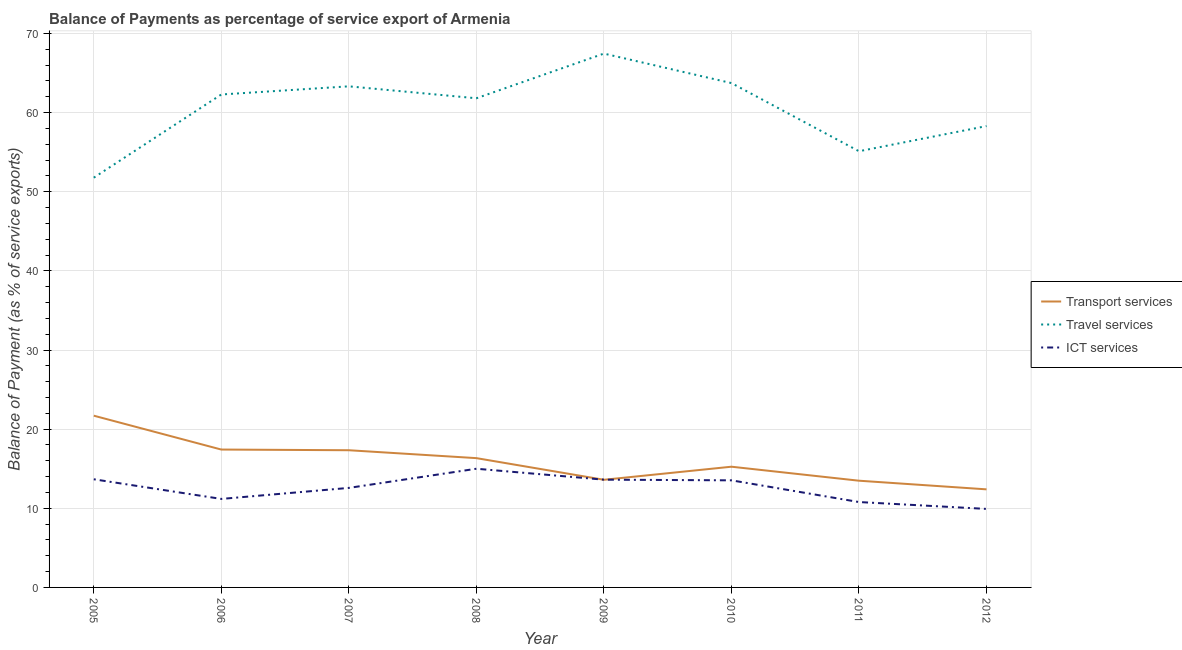Does the line corresponding to balance of payment of ict services intersect with the line corresponding to balance of payment of travel services?
Your answer should be very brief. No. What is the balance of payment of travel services in 2007?
Your answer should be compact. 63.32. Across all years, what is the maximum balance of payment of transport services?
Ensure brevity in your answer.  21.7. Across all years, what is the minimum balance of payment of transport services?
Offer a terse response. 12.39. In which year was the balance of payment of ict services minimum?
Provide a succinct answer. 2012. What is the total balance of payment of ict services in the graph?
Make the answer very short. 100.28. What is the difference between the balance of payment of ict services in 2005 and that in 2006?
Your answer should be compact. 2.48. What is the difference between the balance of payment of transport services in 2008 and the balance of payment of travel services in 2010?
Ensure brevity in your answer.  -47.39. What is the average balance of payment of ict services per year?
Give a very brief answer. 12.54. In the year 2007, what is the difference between the balance of payment of ict services and balance of payment of travel services?
Your response must be concise. -50.74. What is the ratio of the balance of payment of travel services in 2006 to that in 2009?
Offer a very short reply. 0.92. Is the balance of payment of travel services in 2006 less than that in 2008?
Give a very brief answer. No. What is the difference between the highest and the second highest balance of payment of travel services?
Provide a short and direct response. 3.73. What is the difference between the highest and the lowest balance of payment of transport services?
Your answer should be compact. 9.31. Is it the case that in every year, the sum of the balance of payment of transport services and balance of payment of travel services is greater than the balance of payment of ict services?
Provide a short and direct response. Yes. Is the balance of payment of ict services strictly less than the balance of payment of transport services over the years?
Offer a very short reply. No. How many lines are there?
Your answer should be very brief. 3. What is the difference between two consecutive major ticks on the Y-axis?
Ensure brevity in your answer.  10. Are the values on the major ticks of Y-axis written in scientific E-notation?
Provide a short and direct response. No. Where does the legend appear in the graph?
Offer a very short reply. Center right. How many legend labels are there?
Keep it short and to the point. 3. What is the title of the graph?
Ensure brevity in your answer.  Balance of Payments as percentage of service export of Armenia. What is the label or title of the X-axis?
Provide a succinct answer. Year. What is the label or title of the Y-axis?
Your answer should be very brief. Balance of Payment (as % of service exports). What is the Balance of Payment (as % of service exports) in Transport services in 2005?
Your answer should be very brief. 21.7. What is the Balance of Payment (as % of service exports) in Travel services in 2005?
Ensure brevity in your answer.  51.78. What is the Balance of Payment (as % of service exports) in ICT services in 2005?
Provide a succinct answer. 13.67. What is the Balance of Payment (as % of service exports) in Transport services in 2006?
Your answer should be very brief. 17.42. What is the Balance of Payment (as % of service exports) in Travel services in 2006?
Make the answer very short. 62.29. What is the Balance of Payment (as % of service exports) in ICT services in 2006?
Your response must be concise. 11.18. What is the Balance of Payment (as % of service exports) of Transport services in 2007?
Your answer should be very brief. 17.34. What is the Balance of Payment (as % of service exports) in Travel services in 2007?
Give a very brief answer. 63.32. What is the Balance of Payment (as % of service exports) in ICT services in 2007?
Offer a very short reply. 12.58. What is the Balance of Payment (as % of service exports) of Transport services in 2008?
Offer a very short reply. 16.34. What is the Balance of Payment (as % of service exports) in Travel services in 2008?
Your answer should be compact. 61.81. What is the Balance of Payment (as % of service exports) in ICT services in 2008?
Provide a short and direct response. 15. What is the Balance of Payment (as % of service exports) of Transport services in 2009?
Your answer should be compact. 13.6. What is the Balance of Payment (as % of service exports) in Travel services in 2009?
Offer a terse response. 67.46. What is the Balance of Payment (as % of service exports) of ICT services in 2009?
Your response must be concise. 13.62. What is the Balance of Payment (as % of service exports) in Transport services in 2010?
Provide a short and direct response. 15.25. What is the Balance of Payment (as % of service exports) of Travel services in 2010?
Your response must be concise. 63.73. What is the Balance of Payment (as % of service exports) in ICT services in 2010?
Keep it short and to the point. 13.53. What is the Balance of Payment (as % of service exports) of Transport services in 2011?
Your answer should be compact. 13.49. What is the Balance of Payment (as % of service exports) in Travel services in 2011?
Offer a terse response. 55.12. What is the Balance of Payment (as % of service exports) of ICT services in 2011?
Provide a short and direct response. 10.79. What is the Balance of Payment (as % of service exports) of Transport services in 2012?
Provide a succinct answer. 12.39. What is the Balance of Payment (as % of service exports) in Travel services in 2012?
Ensure brevity in your answer.  58.3. What is the Balance of Payment (as % of service exports) of ICT services in 2012?
Keep it short and to the point. 9.92. Across all years, what is the maximum Balance of Payment (as % of service exports) in Transport services?
Offer a very short reply. 21.7. Across all years, what is the maximum Balance of Payment (as % of service exports) of Travel services?
Ensure brevity in your answer.  67.46. Across all years, what is the maximum Balance of Payment (as % of service exports) of ICT services?
Your response must be concise. 15. Across all years, what is the minimum Balance of Payment (as % of service exports) of Transport services?
Offer a terse response. 12.39. Across all years, what is the minimum Balance of Payment (as % of service exports) in Travel services?
Your answer should be compact. 51.78. Across all years, what is the minimum Balance of Payment (as % of service exports) in ICT services?
Your answer should be compact. 9.92. What is the total Balance of Payment (as % of service exports) in Transport services in the graph?
Make the answer very short. 127.53. What is the total Balance of Payment (as % of service exports) in Travel services in the graph?
Your answer should be very brief. 483.8. What is the total Balance of Payment (as % of service exports) in ICT services in the graph?
Give a very brief answer. 100.28. What is the difference between the Balance of Payment (as % of service exports) in Transport services in 2005 and that in 2006?
Ensure brevity in your answer.  4.28. What is the difference between the Balance of Payment (as % of service exports) of Travel services in 2005 and that in 2006?
Offer a very short reply. -10.51. What is the difference between the Balance of Payment (as % of service exports) of ICT services in 2005 and that in 2006?
Offer a very short reply. 2.48. What is the difference between the Balance of Payment (as % of service exports) in Transport services in 2005 and that in 2007?
Make the answer very short. 4.37. What is the difference between the Balance of Payment (as % of service exports) in Travel services in 2005 and that in 2007?
Your answer should be compact. -11.54. What is the difference between the Balance of Payment (as % of service exports) of ICT services in 2005 and that in 2007?
Provide a succinct answer. 1.09. What is the difference between the Balance of Payment (as % of service exports) of Transport services in 2005 and that in 2008?
Offer a terse response. 5.36. What is the difference between the Balance of Payment (as % of service exports) in Travel services in 2005 and that in 2008?
Offer a terse response. -10.03. What is the difference between the Balance of Payment (as % of service exports) of ICT services in 2005 and that in 2008?
Make the answer very short. -1.33. What is the difference between the Balance of Payment (as % of service exports) in Transport services in 2005 and that in 2009?
Ensure brevity in your answer.  8.1. What is the difference between the Balance of Payment (as % of service exports) of Travel services in 2005 and that in 2009?
Your answer should be very brief. -15.68. What is the difference between the Balance of Payment (as % of service exports) of ICT services in 2005 and that in 2009?
Provide a short and direct response. 0.05. What is the difference between the Balance of Payment (as % of service exports) of Transport services in 2005 and that in 2010?
Ensure brevity in your answer.  6.45. What is the difference between the Balance of Payment (as % of service exports) of Travel services in 2005 and that in 2010?
Offer a very short reply. -11.95. What is the difference between the Balance of Payment (as % of service exports) of ICT services in 2005 and that in 2010?
Your response must be concise. 0.13. What is the difference between the Balance of Payment (as % of service exports) of Transport services in 2005 and that in 2011?
Offer a terse response. 8.22. What is the difference between the Balance of Payment (as % of service exports) in Travel services in 2005 and that in 2011?
Keep it short and to the point. -3.34. What is the difference between the Balance of Payment (as % of service exports) of ICT services in 2005 and that in 2011?
Your response must be concise. 2.88. What is the difference between the Balance of Payment (as % of service exports) in Transport services in 2005 and that in 2012?
Provide a short and direct response. 9.31. What is the difference between the Balance of Payment (as % of service exports) in Travel services in 2005 and that in 2012?
Keep it short and to the point. -6.52. What is the difference between the Balance of Payment (as % of service exports) of ICT services in 2005 and that in 2012?
Keep it short and to the point. 3.75. What is the difference between the Balance of Payment (as % of service exports) of Transport services in 2006 and that in 2007?
Offer a terse response. 0.09. What is the difference between the Balance of Payment (as % of service exports) in Travel services in 2006 and that in 2007?
Your answer should be very brief. -1.03. What is the difference between the Balance of Payment (as % of service exports) in ICT services in 2006 and that in 2007?
Your answer should be compact. -1.39. What is the difference between the Balance of Payment (as % of service exports) in Transport services in 2006 and that in 2008?
Your answer should be very brief. 1.08. What is the difference between the Balance of Payment (as % of service exports) in Travel services in 2006 and that in 2008?
Make the answer very short. 0.48. What is the difference between the Balance of Payment (as % of service exports) of ICT services in 2006 and that in 2008?
Provide a succinct answer. -3.81. What is the difference between the Balance of Payment (as % of service exports) of Transport services in 2006 and that in 2009?
Give a very brief answer. 3.82. What is the difference between the Balance of Payment (as % of service exports) of Travel services in 2006 and that in 2009?
Provide a short and direct response. -5.17. What is the difference between the Balance of Payment (as % of service exports) of ICT services in 2006 and that in 2009?
Make the answer very short. -2.43. What is the difference between the Balance of Payment (as % of service exports) of Transport services in 2006 and that in 2010?
Make the answer very short. 2.17. What is the difference between the Balance of Payment (as % of service exports) of Travel services in 2006 and that in 2010?
Ensure brevity in your answer.  -1.44. What is the difference between the Balance of Payment (as % of service exports) in ICT services in 2006 and that in 2010?
Offer a terse response. -2.35. What is the difference between the Balance of Payment (as % of service exports) in Transport services in 2006 and that in 2011?
Provide a succinct answer. 3.94. What is the difference between the Balance of Payment (as % of service exports) in Travel services in 2006 and that in 2011?
Your answer should be very brief. 7.17. What is the difference between the Balance of Payment (as % of service exports) of ICT services in 2006 and that in 2011?
Give a very brief answer. 0.4. What is the difference between the Balance of Payment (as % of service exports) in Transport services in 2006 and that in 2012?
Your response must be concise. 5.03. What is the difference between the Balance of Payment (as % of service exports) in Travel services in 2006 and that in 2012?
Keep it short and to the point. 3.99. What is the difference between the Balance of Payment (as % of service exports) in ICT services in 2006 and that in 2012?
Provide a succinct answer. 1.26. What is the difference between the Balance of Payment (as % of service exports) in Travel services in 2007 and that in 2008?
Your answer should be compact. 1.51. What is the difference between the Balance of Payment (as % of service exports) of ICT services in 2007 and that in 2008?
Provide a short and direct response. -2.42. What is the difference between the Balance of Payment (as % of service exports) of Transport services in 2007 and that in 2009?
Your answer should be compact. 3.73. What is the difference between the Balance of Payment (as % of service exports) in Travel services in 2007 and that in 2009?
Your answer should be compact. -4.14. What is the difference between the Balance of Payment (as % of service exports) in ICT services in 2007 and that in 2009?
Your response must be concise. -1.04. What is the difference between the Balance of Payment (as % of service exports) of Transport services in 2007 and that in 2010?
Provide a short and direct response. 2.08. What is the difference between the Balance of Payment (as % of service exports) in Travel services in 2007 and that in 2010?
Provide a succinct answer. -0.41. What is the difference between the Balance of Payment (as % of service exports) of ICT services in 2007 and that in 2010?
Your answer should be compact. -0.96. What is the difference between the Balance of Payment (as % of service exports) in Transport services in 2007 and that in 2011?
Keep it short and to the point. 3.85. What is the difference between the Balance of Payment (as % of service exports) of Travel services in 2007 and that in 2011?
Keep it short and to the point. 8.2. What is the difference between the Balance of Payment (as % of service exports) in ICT services in 2007 and that in 2011?
Offer a very short reply. 1.79. What is the difference between the Balance of Payment (as % of service exports) in Transport services in 2007 and that in 2012?
Offer a very short reply. 4.94. What is the difference between the Balance of Payment (as % of service exports) in Travel services in 2007 and that in 2012?
Give a very brief answer. 5.02. What is the difference between the Balance of Payment (as % of service exports) in ICT services in 2007 and that in 2012?
Your answer should be very brief. 2.66. What is the difference between the Balance of Payment (as % of service exports) in Transport services in 2008 and that in 2009?
Your answer should be very brief. 2.73. What is the difference between the Balance of Payment (as % of service exports) in Travel services in 2008 and that in 2009?
Your answer should be very brief. -5.65. What is the difference between the Balance of Payment (as % of service exports) of ICT services in 2008 and that in 2009?
Make the answer very short. 1.38. What is the difference between the Balance of Payment (as % of service exports) in Transport services in 2008 and that in 2010?
Provide a succinct answer. 1.08. What is the difference between the Balance of Payment (as % of service exports) of Travel services in 2008 and that in 2010?
Give a very brief answer. -1.92. What is the difference between the Balance of Payment (as % of service exports) of ICT services in 2008 and that in 2010?
Your response must be concise. 1.47. What is the difference between the Balance of Payment (as % of service exports) of Transport services in 2008 and that in 2011?
Your answer should be compact. 2.85. What is the difference between the Balance of Payment (as % of service exports) in Travel services in 2008 and that in 2011?
Ensure brevity in your answer.  6.69. What is the difference between the Balance of Payment (as % of service exports) in ICT services in 2008 and that in 2011?
Make the answer very short. 4.21. What is the difference between the Balance of Payment (as % of service exports) in Transport services in 2008 and that in 2012?
Make the answer very short. 3.94. What is the difference between the Balance of Payment (as % of service exports) in Travel services in 2008 and that in 2012?
Your answer should be very brief. 3.51. What is the difference between the Balance of Payment (as % of service exports) in ICT services in 2008 and that in 2012?
Make the answer very short. 5.08. What is the difference between the Balance of Payment (as % of service exports) in Transport services in 2009 and that in 2010?
Your answer should be compact. -1.65. What is the difference between the Balance of Payment (as % of service exports) in Travel services in 2009 and that in 2010?
Offer a terse response. 3.73. What is the difference between the Balance of Payment (as % of service exports) of ICT services in 2009 and that in 2010?
Offer a very short reply. 0.08. What is the difference between the Balance of Payment (as % of service exports) in Transport services in 2009 and that in 2011?
Provide a succinct answer. 0.12. What is the difference between the Balance of Payment (as % of service exports) of Travel services in 2009 and that in 2011?
Make the answer very short. 12.34. What is the difference between the Balance of Payment (as % of service exports) in ICT services in 2009 and that in 2011?
Make the answer very short. 2.83. What is the difference between the Balance of Payment (as % of service exports) in Transport services in 2009 and that in 2012?
Ensure brevity in your answer.  1.21. What is the difference between the Balance of Payment (as % of service exports) in Travel services in 2009 and that in 2012?
Your answer should be very brief. 9.16. What is the difference between the Balance of Payment (as % of service exports) of ICT services in 2009 and that in 2012?
Provide a succinct answer. 3.7. What is the difference between the Balance of Payment (as % of service exports) in Transport services in 2010 and that in 2011?
Give a very brief answer. 1.77. What is the difference between the Balance of Payment (as % of service exports) in Travel services in 2010 and that in 2011?
Your answer should be very brief. 8.61. What is the difference between the Balance of Payment (as % of service exports) in ICT services in 2010 and that in 2011?
Keep it short and to the point. 2.74. What is the difference between the Balance of Payment (as % of service exports) in Transport services in 2010 and that in 2012?
Keep it short and to the point. 2.86. What is the difference between the Balance of Payment (as % of service exports) of Travel services in 2010 and that in 2012?
Offer a terse response. 5.43. What is the difference between the Balance of Payment (as % of service exports) in ICT services in 2010 and that in 2012?
Your answer should be very brief. 3.61. What is the difference between the Balance of Payment (as % of service exports) in Transport services in 2011 and that in 2012?
Ensure brevity in your answer.  1.09. What is the difference between the Balance of Payment (as % of service exports) in Travel services in 2011 and that in 2012?
Your response must be concise. -3.18. What is the difference between the Balance of Payment (as % of service exports) of ICT services in 2011 and that in 2012?
Your answer should be very brief. 0.87. What is the difference between the Balance of Payment (as % of service exports) in Transport services in 2005 and the Balance of Payment (as % of service exports) in Travel services in 2006?
Provide a short and direct response. -40.59. What is the difference between the Balance of Payment (as % of service exports) of Transport services in 2005 and the Balance of Payment (as % of service exports) of ICT services in 2006?
Ensure brevity in your answer.  10.52. What is the difference between the Balance of Payment (as % of service exports) in Travel services in 2005 and the Balance of Payment (as % of service exports) in ICT services in 2006?
Offer a very short reply. 40.59. What is the difference between the Balance of Payment (as % of service exports) of Transport services in 2005 and the Balance of Payment (as % of service exports) of Travel services in 2007?
Keep it short and to the point. -41.62. What is the difference between the Balance of Payment (as % of service exports) in Transport services in 2005 and the Balance of Payment (as % of service exports) in ICT services in 2007?
Offer a terse response. 9.13. What is the difference between the Balance of Payment (as % of service exports) of Travel services in 2005 and the Balance of Payment (as % of service exports) of ICT services in 2007?
Provide a short and direct response. 39.2. What is the difference between the Balance of Payment (as % of service exports) in Transport services in 2005 and the Balance of Payment (as % of service exports) in Travel services in 2008?
Your response must be concise. -40.11. What is the difference between the Balance of Payment (as % of service exports) of Transport services in 2005 and the Balance of Payment (as % of service exports) of ICT services in 2008?
Your answer should be compact. 6.7. What is the difference between the Balance of Payment (as % of service exports) in Travel services in 2005 and the Balance of Payment (as % of service exports) in ICT services in 2008?
Offer a very short reply. 36.78. What is the difference between the Balance of Payment (as % of service exports) of Transport services in 2005 and the Balance of Payment (as % of service exports) of Travel services in 2009?
Offer a very short reply. -45.75. What is the difference between the Balance of Payment (as % of service exports) in Transport services in 2005 and the Balance of Payment (as % of service exports) in ICT services in 2009?
Offer a very short reply. 8.09. What is the difference between the Balance of Payment (as % of service exports) of Travel services in 2005 and the Balance of Payment (as % of service exports) of ICT services in 2009?
Make the answer very short. 38.16. What is the difference between the Balance of Payment (as % of service exports) of Transport services in 2005 and the Balance of Payment (as % of service exports) of Travel services in 2010?
Your answer should be compact. -42.03. What is the difference between the Balance of Payment (as % of service exports) of Transport services in 2005 and the Balance of Payment (as % of service exports) of ICT services in 2010?
Ensure brevity in your answer.  8.17. What is the difference between the Balance of Payment (as % of service exports) in Travel services in 2005 and the Balance of Payment (as % of service exports) in ICT services in 2010?
Your answer should be very brief. 38.24. What is the difference between the Balance of Payment (as % of service exports) of Transport services in 2005 and the Balance of Payment (as % of service exports) of Travel services in 2011?
Ensure brevity in your answer.  -33.42. What is the difference between the Balance of Payment (as % of service exports) in Transport services in 2005 and the Balance of Payment (as % of service exports) in ICT services in 2011?
Keep it short and to the point. 10.91. What is the difference between the Balance of Payment (as % of service exports) in Travel services in 2005 and the Balance of Payment (as % of service exports) in ICT services in 2011?
Give a very brief answer. 40.99. What is the difference between the Balance of Payment (as % of service exports) in Transport services in 2005 and the Balance of Payment (as % of service exports) in Travel services in 2012?
Make the answer very short. -36.6. What is the difference between the Balance of Payment (as % of service exports) of Transport services in 2005 and the Balance of Payment (as % of service exports) of ICT services in 2012?
Make the answer very short. 11.78. What is the difference between the Balance of Payment (as % of service exports) in Travel services in 2005 and the Balance of Payment (as % of service exports) in ICT services in 2012?
Your response must be concise. 41.86. What is the difference between the Balance of Payment (as % of service exports) in Transport services in 2006 and the Balance of Payment (as % of service exports) in Travel services in 2007?
Provide a succinct answer. -45.9. What is the difference between the Balance of Payment (as % of service exports) in Transport services in 2006 and the Balance of Payment (as % of service exports) in ICT services in 2007?
Offer a very short reply. 4.85. What is the difference between the Balance of Payment (as % of service exports) of Travel services in 2006 and the Balance of Payment (as % of service exports) of ICT services in 2007?
Your answer should be very brief. 49.71. What is the difference between the Balance of Payment (as % of service exports) of Transport services in 2006 and the Balance of Payment (as % of service exports) of Travel services in 2008?
Give a very brief answer. -44.39. What is the difference between the Balance of Payment (as % of service exports) in Transport services in 2006 and the Balance of Payment (as % of service exports) in ICT services in 2008?
Make the answer very short. 2.42. What is the difference between the Balance of Payment (as % of service exports) of Travel services in 2006 and the Balance of Payment (as % of service exports) of ICT services in 2008?
Keep it short and to the point. 47.29. What is the difference between the Balance of Payment (as % of service exports) of Transport services in 2006 and the Balance of Payment (as % of service exports) of Travel services in 2009?
Give a very brief answer. -50.04. What is the difference between the Balance of Payment (as % of service exports) of Transport services in 2006 and the Balance of Payment (as % of service exports) of ICT services in 2009?
Give a very brief answer. 3.81. What is the difference between the Balance of Payment (as % of service exports) in Travel services in 2006 and the Balance of Payment (as % of service exports) in ICT services in 2009?
Ensure brevity in your answer.  48.67. What is the difference between the Balance of Payment (as % of service exports) of Transport services in 2006 and the Balance of Payment (as % of service exports) of Travel services in 2010?
Offer a very short reply. -46.31. What is the difference between the Balance of Payment (as % of service exports) of Transport services in 2006 and the Balance of Payment (as % of service exports) of ICT services in 2010?
Keep it short and to the point. 3.89. What is the difference between the Balance of Payment (as % of service exports) of Travel services in 2006 and the Balance of Payment (as % of service exports) of ICT services in 2010?
Ensure brevity in your answer.  48.76. What is the difference between the Balance of Payment (as % of service exports) of Transport services in 2006 and the Balance of Payment (as % of service exports) of Travel services in 2011?
Give a very brief answer. -37.7. What is the difference between the Balance of Payment (as % of service exports) in Transport services in 2006 and the Balance of Payment (as % of service exports) in ICT services in 2011?
Make the answer very short. 6.63. What is the difference between the Balance of Payment (as % of service exports) of Travel services in 2006 and the Balance of Payment (as % of service exports) of ICT services in 2011?
Your answer should be very brief. 51.5. What is the difference between the Balance of Payment (as % of service exports) in Transport services in 2006 and the Balance of Payment (as % of service exports) in Travel services in 2012?
Your answer should be compact. -40.88. What is the difference between the Balance of Payment (as % of service exports) in Transport services in 2006 and the Balance of Payment (as % of service exports) in ICT services in 2012?
Provide a short and direct response. 7.5. What is the difference between the Balance of Payment (as % of service exports) of Travel services in 2006 and the Balance of Payment (as % of service exports) of ICT services in 2012?
Your answer should be compact. 52.37. What is the difference between the Balance of Payment (as % of service exports) of Transport services in 2007 and the Balance of Payment (as % of service exports) of Travel services in 2008?
Your answer should be very brief. -44.48. What is the difference between the Balance of Payment (as % of service exports) of Transport services in 2007 and the Balance of Payment (as % of service exports) of ICT services in 2008?
Provide a succinct answer. 2.34. What is the difference between the Balance of Payment (as % of service exports) of Travel services in 2007 and the Balance of Payment (as % of service exports) of ICT services in 2008?
Offer a very short reply. 48.32. What is the difference between the Balance of Payment (as % of service exports) in Transport services in 2007 and the Balance of Payment (as % of service exports) in Travel services in 2009?
Provide a succinct answer. -50.12. What is the difference between the Balance of Payment (as % of service exports) in Transport services in 2007 and the Balance of Payment (as % of service exports) in ICT services in 2009?
Ensure brevity in your answer.  3.72. What is the difference between the Balance of Payment (as % of service exports) in Travel services in 2007 and the Balance of Payment (as % of service exports) in ICT services in 2009?
Offer a terse response. 49.7. What is the difference between the Balance of Payment (as % of service exports) in Transport services in 2007 and the Balance of Payment (as % of service exports) in Travel services in 2010?
Offer a terse response. -46.4. What is the difference between the Balance of Payment (as % of service exports) in Transport services in 2007 and the Balance of Payment (as % of service exports) in ICT services in 2010?
Provide a succinct answer. 3.8. What is the difference between the Balance of Payment (as % of service exports) of Travel services in 2007 and the Balance of Payment (as % of service exports) of ICT services in 2010?
Offer a very short reply. 49.79. What is the difference between the Balance of Payment (as % of service exports) in Transport services in 2007 and the Balance of Payment (as % of service exports) in Travel services in 2011?
Keep it short and to the point. -37.78. What is the difference between the Balance of Payment (as % of service exports) of Transport services in 2007 and the Balance of Payment (as % of service exports) of ICT services in 2011?
Keep it short and to the point. 6.55. What is the difference between the Balance of Payment (as % of service exports) in Travel services in 2007 and the Balance of Payment (as % of service exports) in ICT services in 2011?
Offer a very short reply. 52.53. What is the difference between the Balance of Payment (as % of service exports) of Transport services in 2007 and the Balance of Payment (as % of service exports) of Travel services in 2012?
Give a very brief answer. -40.96. What is the difference between the Balance of Payment (as % of service exports) of Transport services in 2007 and the Balance of Payment (as % of service exports) of ICT services in 2012?
Ensure brevity in your answer.  7.41. What is the difference between the Balance of Payment (as % of service exports) of Travel services in 2007 and the Balance of Payment (as % of service exports) of ICT services in 2012?
Your answer should be very brief. 53.4. What is the difference between the Balance of Payment (as % of service exports) of Transport services in 2008 and the Balance of Payment (as % of service exports) of Travel services in 2009?
Keep it short and to the point. -51.12. What is the difference between the Balance of Payment (as % of service exports) in Transport services in 2008 and the Balance of Payment (as % of service exports) in ICT services in 2009?
Your answer should be compact. 2.72. What is the difference between the Balance of Payment (as % of service exports) in Travel services in 2008 and the Balance of Payment (as % of service exports) in ICT services in 2009?
Offer a terse response. 48.19. What is the difference between the Balance of Payment (as % of service exports) in Transport services in 2008 and the Balance of Payment (as % of service exports) in Travel services in 2010?
Your answer should be very brief. -47.39. What is the difference between the Balance of Payment (as % of service exports) in Transport services in 2008 and the Balance of Payment (as % of service exports) in ICT services in 2010?
Offer a very short reply. 2.81. What is the difference between the Balance of Payment (as % of service exports) of Travel services in 2008 and the Balance of Payment (as % of service exports) of ICT services in 2010?
Provide a short and direct response. 48.28. What is the difference between the Balance of Payment (as % of service exports) in Transport services in 2008 and the Balance of Payment (as % of service exports) in Travel services in 2011?
Keep it short and to the point. -38.78. What is the difference between the Balance of Payment (as % of service exports) in Transport services in 2008 and the Balance of Payment (as % of service exports) in ICT services in 2011?
Give a very brief answer. 5.55. What is the difference between the Balance of Payment (as % of service exports) of Travel services in 2008 and the Balance of Payment (as % of service exports) of ICT services in 2011?
Give a very brief answer. 51.02. What is the difference between the Balance of Payment (as % of service exports) in Transport services in 2008 and the Balance of Payment (as % of service exports) in Travel services in 2012?
Give a very brief answer. -41.96. What is the difference between the Balance of Payment (as % of service exports) in Transport services in 2008 and the Balance of Payment (as % of service exports) in ICT services in 2012?
Ensure brevity in your answer.  6.42. What is the difference between the Balance of Payment (as % of service exports) of Travel services in 2008 and the Balance of Payment (as % of service exports) of ICT services in 2012?
Offer a very short reply. 51.89. What is the difference between the Balance of Payment (as % of service exports) of Transport services in 2009 and the Balance of Payment (as % of service exports) of Travel services in 2010?
Ensure brevity in your answer.  -50.13. What is the difference between the Balance of Payment (as % of service exports) of Transport services in 2009 and the Balance of Payment (as % of service exports) of ICT services in 2010?
Your answer should be compact. 0.07. What is the difference between the Balance of Payment (as % of service exports) in Travel services in 2009 and the Balance of Payment (as % of service exports) in ICT services in 2010?
Make the answer very short. 53.92. What is the difference between the Balance of Payment (as % of service exports) in Transport services in 2009 and the Balance of Payment (as % of service exports) in Travel services in 2011?
Offer a very short reply. -41.51. What is the difference between the Balance of Payment (as % of service exports) in Transport services in 2009 and the Balance of Payment (as % of service exports) in ICT services in 2011?
Offer a very short reply. 2.81. What is the difference between the Balance of Payment (as % of service exports) in Travel services in 2009 and the Balance of Payment (as % of service exports) in ICT services in 2011?
Provide a short and direct response. 56.67. What is the difference between the Balance of Payment (as % of service exports) in Transport services in 2009 and the Balance of Payment (as % of service exports) in Travel services in 2012?
Your answer should be very brief. -44.69. What is the difference between the Balance of Payment (as % of service exports) in Transport services in 2009 and the Balance of Payment (as % of service exports) in ICT services in 2012?
Give a very brief answer. 3.68. What is the difference between the Balance of Payment (as % of service exports) in Travel services in 2009 and the Balance of Payment (as % of service exports) in ICT services in 2012?
Your answer should be compact. 57.54. What is the difference between the Balance of Payment (as % of service exports) of Transport services in 2010 and the Balance of Payment (as % of service exports) of Travel services in 2011?
Your response must be concise. -39.86. What is the difference between the Balance of Payment (as % of service exports) in Transport services in 2010 and the Balance of Payment (as % of service exports) in ICT services in 2011?
Your answer should be compact. 4.47. What is the difference between the Balance of Payment (as % of service exports) in Travel services in 2010 and the Balance of Payment (as % of service exports) in ICT services in 2011?
Give a very brief answer. 52.94. What is the difference between the Balance of Payment (as % of service exports) in Transport services in 2010 and the Balance of Payment (as % of service exports) in Travel services in 2012?
Provide a short and direct response. -43.04. What is the difference between the Balance of Payment (as % of service exports) of Transport services in 2010 and the Balance of Payment (as % of service exports) of ICT services in 2012?
Your response must be concise. 5.33. What is the difference between the Balance of Payment (as % of service exports) in Travel services in 2010 and the Balance of Payment (as % of service exports) in ICT services in 2012?
Keep it short and to the point. 53.81. What is the difference between the Balance of Payment (as % of service exports) of Transport services in 2011 and the Balance of Payment (as % of service exports) of Travel services in 2012?
Provide a short and direct response. -44.81. What is the difference between the Balance of Payment (as % of service exports) in Transport services in 2011 and the Balance of Payment (as % of service exports) in ICT services in 2012?
Keep it short and to the point. 3.56. What is the difference between the Balance of Payment (as % of service exports) of Travel services in 2011 and the Balance of Payment (as % of service exports) of ICT services in 2012?
Give a very brief answer. 45.2. What is the average Balance of Payment (as % of service exports) of Transport services per year?
Offer a very short reply. 15.94. What is the average Balance of Payment (as % of service exports) in Travel services per year?
Your answer should be very brief. 60.48. What is the average Balance of Payment (as % of service exports) of ICT services per year?
Provide a succinct answer. 12.54. In the year 2005, what is the difference between the Balance of Payment (as % of service exports) of Transport services and Balance of Payment (as % of service exports) of Travel services?
Provide a short and direct response. -30.07. In the year 2005, what is the difference between the Balance of Payment (as % of service exports) of Transport services and Balance of Payment (as % of service exports) of ICT services?
Offer a very short reply. 8.04. In the year 2005, what is the difference between the Balance of Payment (as % of service exports) in Travel services and Balance of Payment (as % of service exports) in ICT services?
Your answer should be very brief. 38.11. In the year 2006, what is the difference between the Balance of Payment (as % of service exports) in Transport services and Balance of Payment (as % of service exports) in Travel services?
Ensure brevity in your answer.  -44.87. In the year 2006, what is the difference between the Balance of Payment (as % of service exports) of Transport services and Balance of Payment (as % of service exports) of ICT services?
Make the answer very short. 6.24. In the year 2006, what is the difference between the Balance of Payment (as % of service exports) of Travel services and Balance of Payment (as % of service exports) of ICT services?
Keep it short and to the point. 51.11. In the year 2007, what is the difference between the Balance of Payment (as % of service exports) in Transport services and Balance of Payment (as % of service exports) in Travel services?
Your answer should be very brief. -45.98. In the year 2007, what is the difference between the Balance of Payment (as % of service exports) in Transport services and Balance of Payment (as % of service exports) in ICT services?
Your answer should be compact. 4.76. In the year 2007, what is the difference between the Balance of Payment (as % of service exports) in Travel services and Balance of Payment (as % of service exports) in ICT services?
Offer a very short reply. 50.74. In the year 2008, what is the difference between the Balance of Payment (as % of service exports) of Transport services and Balance of Payment (as % of service exports) of Travel services?
Your answer should be compact. -45.47. In the year 2008, what is the difference between the Balance of Payment (as % of service exports) of Transport services and Balance of Payment (as % of service exports) of ICT services?
Make the answer very short. 1.34. In the year 2008, what is the difference between the Balance of Payment (as % of service exports) in Travel services and Balance of Payment (as % of service exports) in ICT services?
Your response must be concise. 46.81. In the year 2009, what is the difference between the Balance of Payment (as % of service exports) in Transport services and Balance of Payment (as % of service exports) in Travel services?
Your answer should be very brief. -53.85. In the year 2009, what is the difference between the Balance of Payment (as % of service exports) in Transport services and Balance of Payment (as % of service exports) in ICT services?
Provide a succinct answer. -0.01. In the year 2009, what is the difference between the Balance of Payment (as % of service exports) in Travel services and Balance of Payment (as % of service exports) in ICT services?
Offer a terse response. 53.84. In the year 2010, what is the difference between the Balance of Payment (as % of service exports) of Transport services and Balance of Payment (as % of service exports) of Travel services?
Provide a short and direct response. -48.48. In the year 2010, what is the difference between the Balance of Payment (as % of service exports) in Transport services and Balance of Payment (as % of service exports) in ICT services?
Your response must be concise. 1.72. In the year 2010, what is the difference between the Balance of Payment (as % of service exports) of Travel services and Balance of Payment (as % of service exports) of ICT services?
Ensure brevity in your answer.  50.2. In the year 2011, what is the difference between the Balance of Payment (as % of service exports) in Transport services and Balance of Payment (as % of service exports) in Travel services?
Give a very brief answer. -41.63. In the year 2011, what is the difference between the Balance of Payment (as % of service exports) of Transport services and Balance of Payment (as % of service exports) of ICT services?
Your response must be concise. 2.7. In the year 2011, what is the difference between the Balance of Payment (as % of service exports) in Travel services and Balance of Payment (as % of service exports) in ICT services?
Your answer should be compact. 44.33. In the year 2012, what is the difference between the Balance of Payment (as % of service exports) in Transport services and Balance of Payment (as % of service exports) in Travel services?
Ensure brevity in your answer.  -45.9. In the year 2012, what is the difference between the Balance of Payment (as % of service exports) of Transport services and Balance of Payment (as % of service exports) of ICT services?
Offer a very short reply. 2.47. In the year 2012, what is the difference between the Balance of Payment (as % of service exports) in Travel services and Balance of Payment (as % of service exports) in ICT services?
Offer a terse response. 48.38. What is the ratio of the Balance of Payment (as % of service exports) in Transport services in 2005 to that in 2006?
Ensure brevity in your answer.  1.25. What is the ratio of the Balance of Payment (as % of service exports) in Travel services in 2005 to that in 2006?
Keep it short and to the point. 0.83. What is the ratio of the Balance of Payment (as % of service exports) in ICT services in 2005 to that in 2006?
Provide a succinct answer. 1.22. What is the ratio of the Balance of Payment (as % of service exports) of Transport services in 2005 to that in 2007?
Keep it short and to the point. 1.25. What is the ratio of the Balance of Payment (as % of service exports) of Travel services in 2005 to that in 2007?
Make the answer very short. 0.82. What is the ratio of the Balance of Payment (as % of service exports) of ICT services in 2005 to that in 2007?
Your answer should be very brief. 1.09. What is the ratio of the Balance of Payment (as % of service exports) of Transport services in 2005 to that in 2008?
Provide a short and direct response. 1.33. What is the ratio of the Balance of Payment (as % of service exports) of Travel services in 2005 to that in 2008?
Keep it short and to the point. 0.84. What is the ratio of the Balance of Payment (as % of service exports) of ICT services in 2005 to that in 2008?
Give a very brief answer. 0.91. What is the ratio of the Balance of Payment (as % of service exports) of Transport services in 2005 to that in 2009?
Your answer should be very brief. 1.6. What is the ratio of the Balance of Payment (as % of service exports) in Travel services in 2005 to that in 2009?
Provide a short and direct response. 0.77. What is the ratio of the Balance of Payment (as % of service exports) in ICT services in 2005 to that in 2009?
Give a very brief answer. 1. What is the ratio of the Balance of Payment (as % of service exports) in Transport services in 2005 to that in 2010?
Your response must be concise. 1.42. What is the ratio of the Balance of Payment (as % of service exports) of Travel services in 2005 to that in 2010?
Your answer should be compact. 0.81. What is the ratio of the Balance of Payment (as % of service exports) of ICT services in 2005 to that in 2010?
Make the answer very short. 1.01. What is the ratio of the Balance of Payment (as % of service exports) in Transport services in 2005 to that in 2011?
Provide a short and direct response. 1.61. What is the ratio of the Balance of Payment (as % of service exports) of Travel services in 2005 to that in 2011?
Offer a very short reply. 0.94. What is the ratio of the Balance of Payment (as % of service exports) of ICT services in 2005 to that in 2011?
Provide a succinct answer. 1.27. What is the ratio of the Balance of Payment (as % of service exports) of Transport services in 2005 to that in 2012?
Ensure brevity in your answer.  1.75. What is the ratio of the Balance of Payment (as % of service exports) in Travel services in 2005 to that in 2012?
Offer a terse response. 0.89. What is the ratio of the Balance of Payment (as % of service exports) in ICT services in 2005 to that in 2012?
Your answer should be compact. 1.38. What is the ratio of the Balance of Payment (as % of service exports) of Transport services in 2006 to that in 2007?
Your response must be concise. 1. What is the ratio of the Balance of Payment (as % of service exports) in Travel services in 2006 to that in 2007?
Keep it short and to the point. 0.98. What is the ratio of the Balance of Payment (as % of service exports) in ICT services in 2006 to that in 2007?
Your answer should be compact. 0.89. What is the ratio of the Balance of Payment (as % of service exports) in Transport services in 2006 to that in 2008?
Offer a very short reply. 1.07. What is the ratio of the Balance of Payment (as % of service exports) of Travel services in 2006 to that in 2008?
Keep it short and to the point. 1.01. What is the ratio of the Balance of Payment (as % of service exports) of ICT services in 2006 to that in 2008?
Provide a succinct answer. 0.75. What is the ratio of the Balance of Payment (as % of service exports) of Transport services in 2006 to that in 2009?
Make the answer very short. 1.28. What is the ratio of the Balance of Payment (as % of service exports) of Travel services in 2006 to that in 2009?
Make the answer very short. 0.92. What is the ratio of the Balance of Payment (as % of service exports) in ICT services in 2006 to that in 2009?
Provide a short and direct response. 0.82. What is the ratio of the Balance of Payment (as % of service exports) in Transport services in 2006 to that in 2010?
Offer a very short reply. 1.14. What is the ratio of the Balance of Payment (as % of service exports) in Travel services in 2006 to that in 2010?
Offer a terse response. 0.98. What is the ratio of the Balance of Payment (as % of service exports) in ICT services in 2006 to that in 2010?
Your response must be concise. 0.83. What is the ratio of the Balance of Payment (as % of service exports) of Transport services in 2006 to that in 2011?
Provide a succinct answer. 1.29. What is the ratio of the Balance of Payment (as % of service exports) in Travel services in 2006 to that in 2011?
Your answer should be very brief. 1.13. What is the ratio of the Balance of Payment (as % of service exports) in ICT services in 2006 to that in 2011?
Make the answer very short. 1.04. What is the ratio of the Balance of Payment (as % of service exports) of Transport services in 2006 to that in 2012?
Your answer should be very brief. 1.41. What is the ratio of the Balance of Payment (as % of service exports) in Travel services in 2006 to that in 2012?
Give a very brief answer. 1.07. What is the ratio of the Balance of Payment (as % of service exports) in ICT services in 2006 to that in 2012?
Give a very brief answer. 1.13. What is the ratio of the Balance of Payment (as % of service exports) of Transport services in 2007 to that in 2008?
Your response must be concise. 1.06. What is the ratio of the Balance of Payment (as % of service exports) in Travel services in 2007 to that in 2008?
Offer a terse response. 1.02. What is the ratio of the Balance of Payment (as % of service exports) in ICT services in 2007 to that in 2008?
Give a very brief answer. 0.84. What is the ratio of the Balance of Payment (as % of service exports) of Transport services in 2007 to that in 2009?
Offer a terse response. 1.27. What is the ratio of the Balance of Payment (as % of service exports) of Travel services in 2007 to that in 2009?
Offer a very short reply. 0.94. What is the ratio of the Balance of Payment (as % of service exports) of ICT services in 2007 to that in 2009?
Give a very brief answer. 0.92. What is the ratio of the Balance of Payment (as % of service exports) in Transport services in 2007 to that in 2010?
Offer a terse response. 1.14. What is the ratio of the Balance of Payment (as % of service exports) in Travel services in 2007 to that in 2010?
Offer a terse response. 0.99. What is the ratio of the Balance of Payment (as % of service exports) in ICT services in 2007 to that in 2010?
Keep it short and to the point. 0.93. What is the ratio of the Balance of Payment (as % of service exports) of Transport services in 2007 to that in 2011?
Make the answer very short. 1.29. What is the ratio of the Balance of Payment (as % of service exports) of Travel services in 2007 to that in 2011?
Give a very brief answer. 1.15. What is the ratio of the Balance of Payment (as % of service exports) in ICT services in 2007 to that in 2011?
Make the answer very short. 1.17. What is the ratio of the Balance of Payment (as % of service exports) of Transport services in 2007 to that in 2012?
Give a very brief answer. 1.4. What is the ratio of the Balance of Payment (as % of service exports) of Travel services in 2007 to that in 2012?
Provide a short and direct response. 1.09. What is the ratio of the Balance of Payment (as % of service exports) in ICT services in 2007 to that in 2012?
Keep it short and to the point. 1.27. What is the ratio of the Balance of Payment (as % of service exports) in Transport services in 2008 to that in 2009?
Keep it short and to the point. 1.2. What is the ratio of the Balance of Payment (as % of service exports) of Travel services in 2008 to that in 2009?
Make the answer very short. 0.92. What is the ratio of the Balance of Payment (as % of service exports) in ICT services in 2008 to that in 2009?
Offer a terse response. 1.1. What is the ratio of the Balance of Payment (as % of service exports) of Transport services in 2008 to that in 2010?
Your response must be concise. 1.07. What is the ratio of the Balance of Payment (as % of service exports) of Travel services in 2008 to that in 2010?
Provide a short and direct response. 0.97. What is the ratio of the Balance of Payment (as % of service exports) in ICT services in 2008 to that in 2010?
Your answer should be compact. 1.11. What is the ratio of the Balance of Payment (as % of service exports) in Transport services in 2008 to that in 2011?
Make the answer very short. 1.21. What is the ratio of the Balance of Payment (as % of service exports) of Travel services in 2008 to that in 2011?
Make the answer very short. 1.12. What is the ratio of the Balance of Payment (as % of service exports) in ICT services in 2008 to that in 2011?
Your answer should be compact. 1.39. What is the ratio of the Balance of Payment (as % of service exports) of Transport services in 2008 to that in 2012?
Give a very brief answer. 1.32. What is the ratio of the Balance of Payment (as % of service exports) in Travel services in 2008 to that in 2012?
Offer a very short reply. 1.06. What is the ratio of the Balance of Payment (as % of service exports) of ICT services in 2008 to that in 2012?
Keep it short and to the point. 1.51. What is the ratio of the Balance of Payment (as % of service exports) in Transport services in 2009 to that in 2010?
Your answer should be very brief. 0.89. What is the ratio of the Balance of Payment (as % of service exports) of Travel services in 2009 to that in 2010?
Provide a short and direct response. 1.06. What is the ratio of the Balance of Payment (as % of service exports) in Transport services in 2009 to that in 2011?
Offer a terse response. 1.01. What is the ratio of the Balance of Payment (as % of service exports) in Travel services in 2009 to that in 2011?
Ensure brevity in your answer.  1.22. What is the ratio of the Balance of Payment (as % of service exports) of ICT services in 2009 to that in 2011?
Give a very brief answer. 1.26. What is the ratio of the Balance of Payment (as % of service exports) of Transport services in 2009 to that in 2012?
Provide a short and direct response. 1.1. What is the ratio of the Balance of Payment (as % of service exports) of Travel services in 2009 to that in 2012?
Make the answer very short. 1.16. What is the ratio of the Balance of Payment (as % of service exports) in ICT services in 2009 to that in 2012?
Ensure brevity in your answer.  1.37. What is the ratio of the Balance of Payment (as % of service exports) of Transport services in 2010 to that in 2011?
Provide a succinct answer. 1.13. What is the ratio of the Balance of Payment (as % of service exports) in Travel services in 2010 to that in 2011?
Provide a succinct answer. 1.16. What is the ratio of the Balance of Payment (as % of service exports) in ICT services in 2010 to that in 2011?
Your answer should be compact. 1.25. What is the ratio of the Balance of Payment (as % of service exports) in Transport services in 2010 to that in 2012?
Provide a short and direct response. 1.23. What is the ratio of the Balance of Payment (as % of service exports) in Travel services in 2010 to that in 2012?
Offer a terse response. 1.09. What is the ratio of the Balance of Payment (as % of service exports) in ICT services in 2010 to that in 2012?
Provide a succinct answer. 1.36. What is the ratio of the Balance of Payment (as % of service exports) of Transport services in 2011 to that in 2012?
Provide a succinct answer. 1.09. What is the ratio of the Balance of Payment (as % of service exports) of Travel services in 2011 to that in 2012?
Your answer should be very brief. 0.95. What is the ratio of the Balance of Payment (as % of service exports) of ICT services in 2011 to that in 2012?
Your response must be concise. 1.09. What is the difference between the highest and the second highest Balance of Payment (as % of service exports) of Transport services?
Your answer should be very brief. 4.28. What is the difference between the highest and the second highest Balance of Payment (as % of service exports) in Travel services?
Your answer should be very brief. 3.73. What is the difference between the highest and the second highest Balance of Payment (as % of service exports) of ICT services?
Keep it short and to the point. 1.33. What is the difference between the highest and the lowest Balance of Payment (as % of service exports) in Transport services?
Provide a short and direct response. 9.31. What is the difference between the highest and the lowest Balance of Payment (as % of service exports) in Travel services?
Your response must be concise. 15.68. What is the difference between the highest and the lowest Balance of Payment (as % of service exports) in ICT services?
Offer a very short reply. 5.08. 